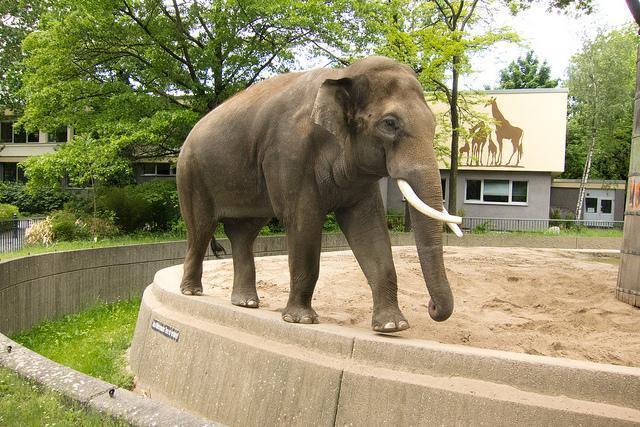How many dogs are sleeping in the image ?
Give a very brief answer. 0. 